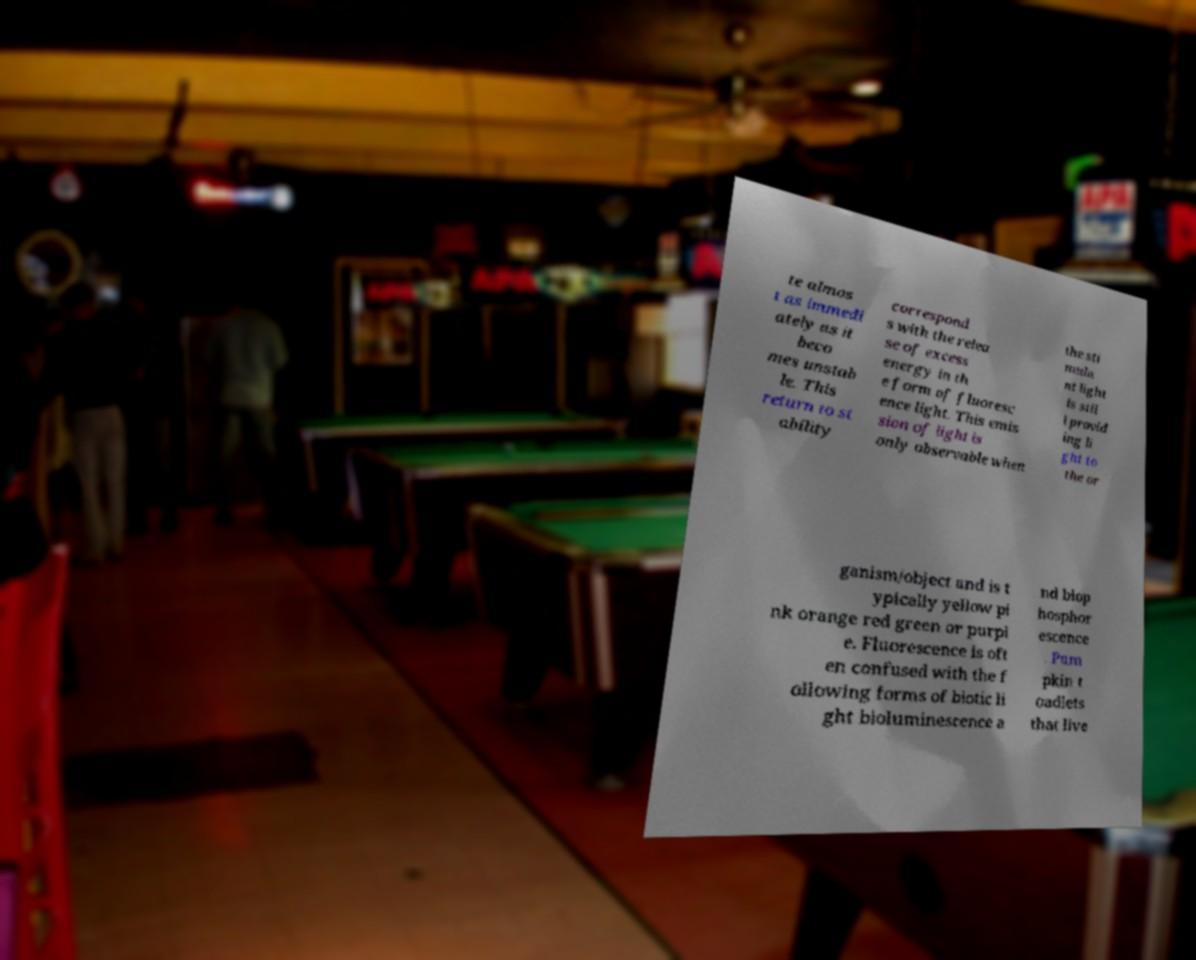Please read and relay the text visible in this image. What does it say? te almos t as immedi ately as it beco mes unstab le. This return to st ability correspond s with the relea se of excess energy in th e form of fluoresc ence light. This emis sion of light is only observable when the sti mula nt light is stil l provid ing li ght to the or ganism/object and is t ypically yellow pi nk orange red green or purpl e. Fluorescence is oft en confused with the f ollowing forms of biotic li ght bioluminescence a nd biop hosphor escence . Pum pkin t oadlets that live 